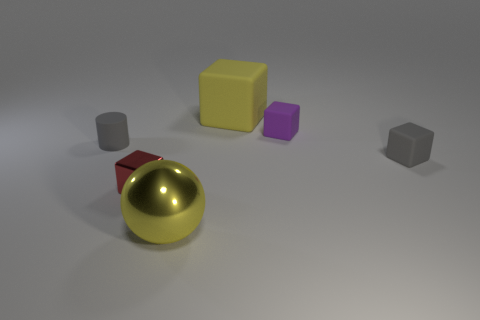Is the material of the small block that is left of the big yellow metallic thing the same as the tiny cylinder?
Keep it short and to the point. No. What material is the yellow thing in front of the tiny block on the left side of the large object that is in front of the tiny purple rubber object?
Keep it short and to the point. Metal. There is a red block that is the same size as the purple object; what is its material?
Your response must be concise. Metal. There is a tiny gray rubber object that is on the left side of the small red shiny cube; what is its shape?
Provide a succinct answer. Cylinder. Is the material of the thing in front of the red shiny thing the same as the small gray thing to the right of the big metal thing?
Your answer should be very brief. No. What number of large yellow matte things are the same shape as the small purple object?
Provide a succinct answer. 1. What material is the thing that is the same color as the big rubber cube?
Your answer should be very brief. Metal. How many objects are gray matte objects or tiny cubes behind the small red metallic object?
Provide a succinct answer. 3. What is the tiny red object made of?
Your answer should be compact. Metal. There is a tiny red thing that is the same shape as the big rubber object; what is its material?
Give a very brief answer. Metal. 